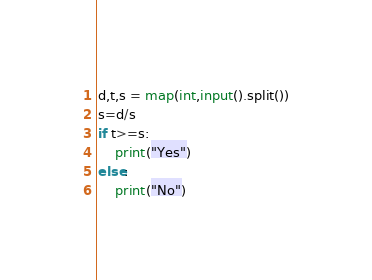<code> <loc_0><loc_0><loc_500><loc_500><_Python_>d,t,s = map(int,input().split())
s=d/s
if t>=s:
    print("Yes")
else:
    print("No")</code> 